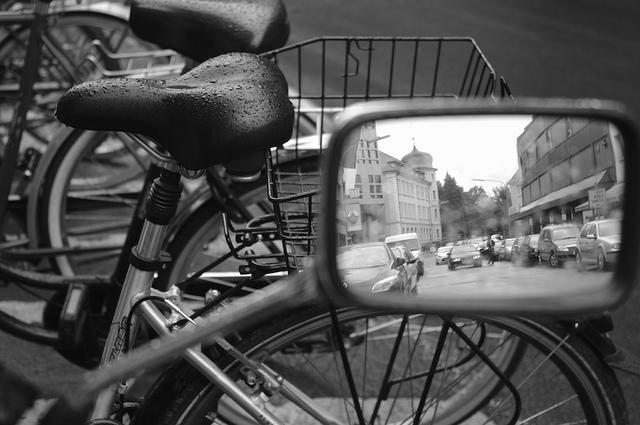Why is the black bike seat wet? rain 